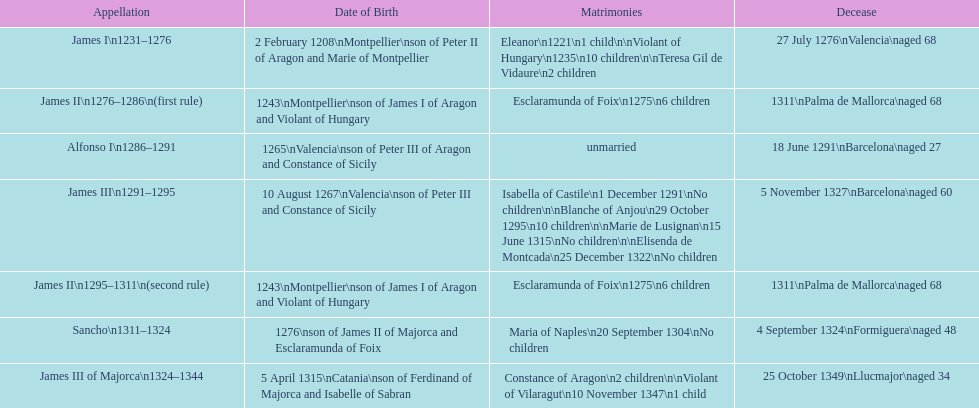James i and james ii both died at what age? 68. 